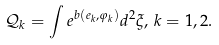Convert formula to latex. <formula><loc_0><loc_0><loc_500><loc_500>\mathcal { Q } _ { k } = \int e ^ { b ( e _ { k } , \varphi _ { k } ) } d ^ { 2 } \xi , \, k = 1 , 2 .</formula> 